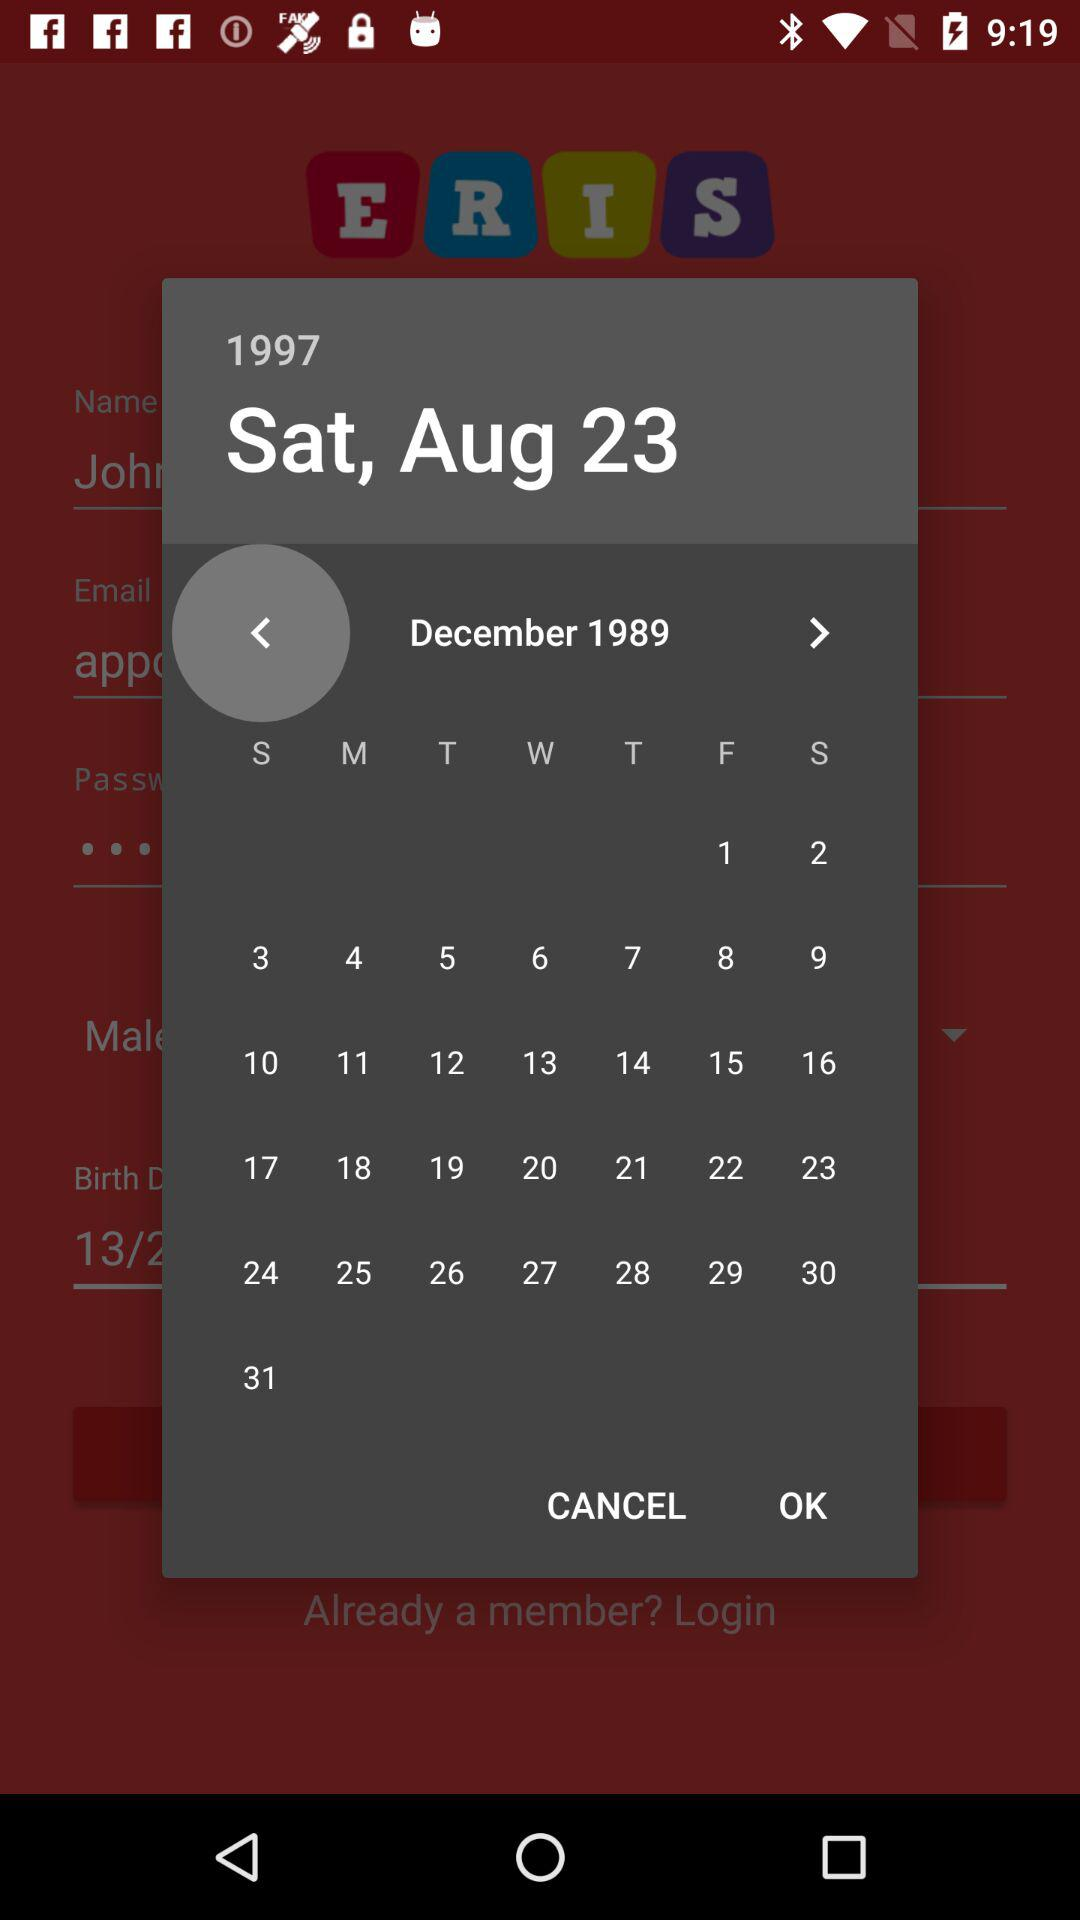What is the selected date? The selected date is Saturday, August 23, 1997. 